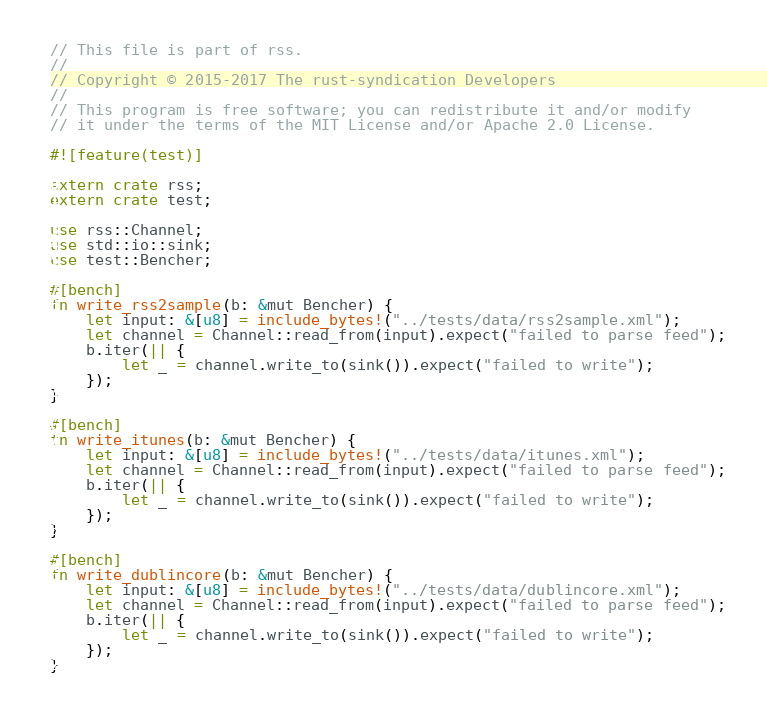<code> <loc_0><loc_0><loc_500><loc_500><_Rust_>// This file is part of rss.
//
// Copyright © 2015-2017 The rust-syndication Developers
//
// This program is free software; you can redistribute it and/or modify
// it under the terms of the MIT License and/or Apache 2.0 License.

#![feature(test)]

extern crate rss;
extern crate test;

use rss::Channel;
use std::io::sink;
use test::Bencher;

#[bench]
fn write_rss2sample(b: &mut Bencher) {
    let input: &[u8] = include_bytes!("../tests/data/rss2sample.xml");
    let channel = Channel::read_from(input).expect("failed to parse feed");
    b.iter(|| {
        let _ = channel.write_to(sink()).expect("failed to write");
    });
}

#[bench]
fn write_itunes(b: &mut Bencher) {
    let input: &[u8] = include_bytes!("../tests/data/itunes.xml");
    let channel = Channel::read_from(input).expect("failed to parse feed");
    b.iter(|| {
        let _ = channel.write_to(sink()).expect("failed to write");
    });
}

#[bench]
fn write_dublincore(b: &mut Bencher) {
    let input: &[u8] = include_bytes!("../tests/data/dublincore.xml");
    let channel = Channel::read_from(input).expect("failed to parse feed");
    b.iter(|| {
        let _ = channel.write_to(sink()).expect("failed to write");
    });
}
</code> 